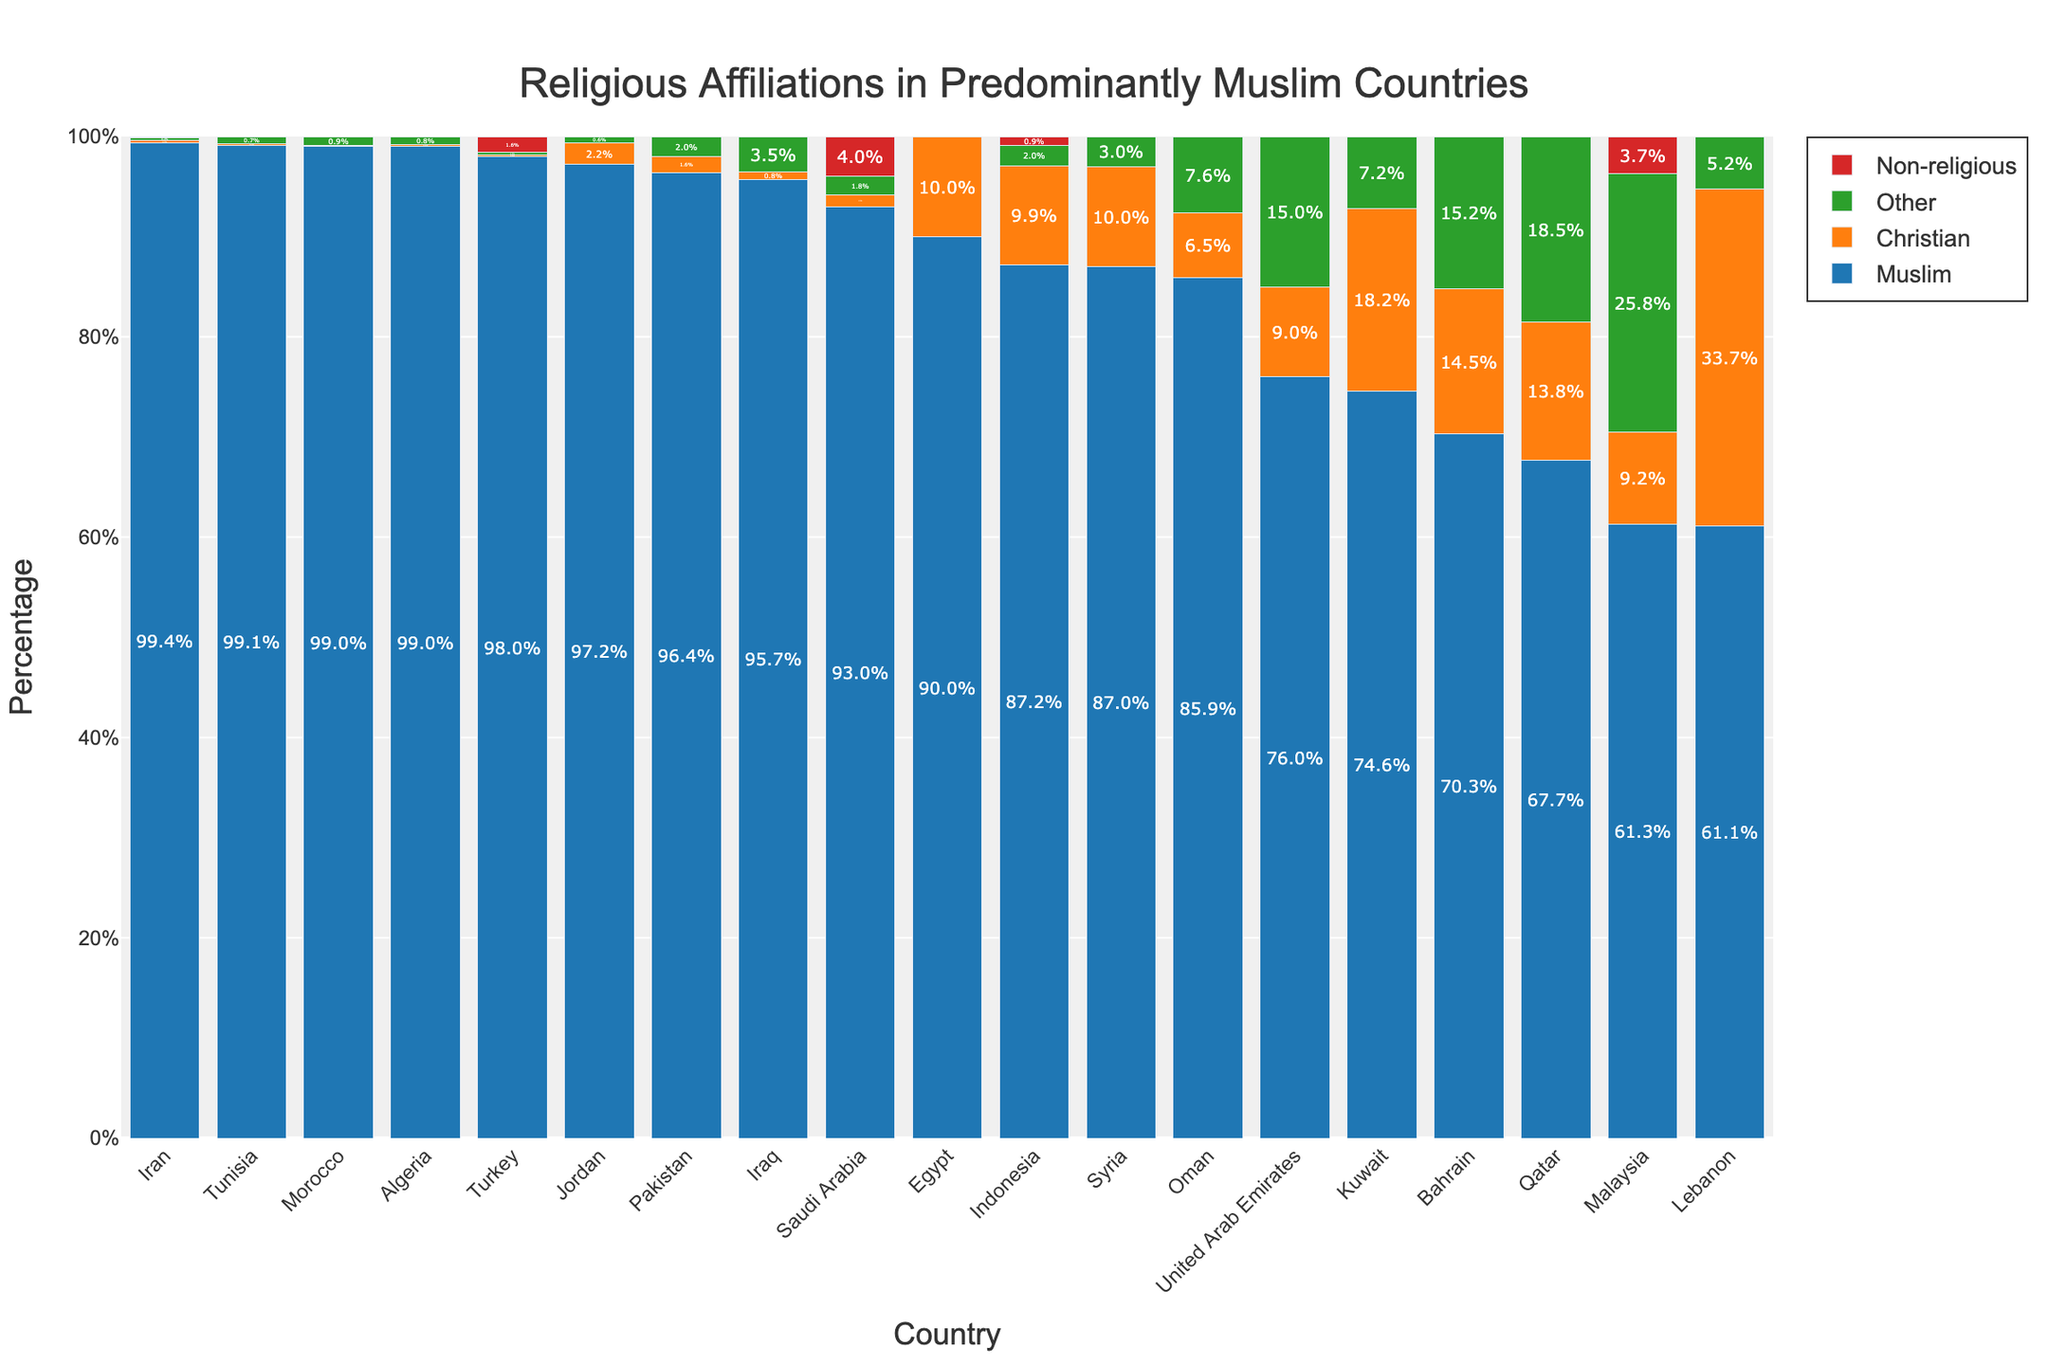Which country has the highest percentage of Muslims? By looking at the tallest blue bar, which represents Muslims, the country with the highest percentage of Muslims is found to be Iran.
Answer: Iran Which country has the largest percentage of Christians? By examining the height of the orange bars representing Christians, Lebanon has the largest percentage of Christians.
Answer: Lebanon What is the combined percentage of non-religious people in Turkey and Saudi Arabia? Add the percentage of non-religious people in Turkey (1.6%) to that in Saudi Arabia (4.0%).
Answer: 5.6% Which countries have a higher percentage of "Other" religious affiliations than Christians? Compare the green bars (Other) and orange bars (Christian) to identify which countries have taller green bars than orange bars. From the chart, Malaysia, United Arab Emirates, Bahrain, Qatar, and Oman have larger "Other" percentages than Christian percentages.
Answer: Malaysia, United Arab Emirates, Bahrain, Qatar, Oman In which country is the difference between the Muslim and Christian populations the smallest? Calculate the difference between the height of the blue (Muslim) and orange (Christian) bars for each country. Lebanon has the smallest difference, with Muslims at 61.1% and Christians at 33.7%, a difference of 27.4%.
Answer: Lebanon What is the average percentage of Muslims across all listed countries? Sum the percentages of Muslims in all countries and divide by the number of countries: (98.0 + 99.4 + 93.0 + 90.0 + 87.2 + 96.4 + 61.3 + 61.1 + 87.0 + 97.2 + 76.0 + 95.7 + 74.6 + 70.3 + 67.7 + 85.9 + 99.0 + 99.0 + 99.1) / 19 = 85.1%
Answer: 85.1% Which country has the most balanced distribution of religious affiliations? Identify the country where the heights of blue, orange, green, and red bars are relatively close to each other. Malaysia has Muslim 61.3%, Christian 9.2%, Other 25.8%, and Non-religious 3.7%, indicating a more balanced distribution.
Answer: Malaysia How does the percentage of Christians in Egypt compare to that in Syria? Compare the orange bars between Egypt (10.0%) and Syria (10.0%). Both countries have the same percentage of Christians.
Answer: Equal In which countries is the percentage of 'Non-religious' highest? Look for the tallest red bars representing 'Non-religious'. Turkey (1.6%), Saudi Arabia (4.0%), Indonesia (0.9%), and Malaysia (3.7%) are the countries with the highest percentage of Non-religious populations.
Answer: Saudi Arabia What is the total percentage of non-Muslim populations in Qatar? Sum the percentages of Christians (13.8%), Other (18.5%), and Non-religious (0.0%) in Qatar.
Answer: 32.3% 